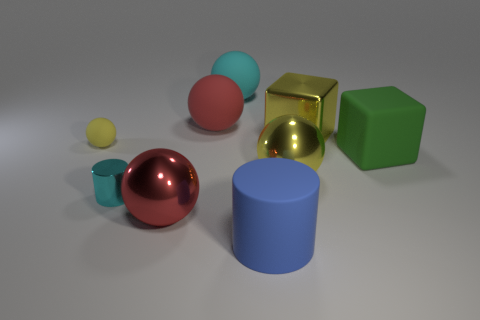Subtract all small yellow matte balls. How many balls are left? 4 Subtract all gray balls. Subtract all green cylinders. How many balls are left? 5 Add 1 large objects. How many objects exist? 10 Subtract all cylinders. How many objects are left? 7 Add 5 big matte cubes. How many big matte cubes exist? 6 Subtract 0 blue spheres. How many objects are left? 9 Subtract all tiny yellow cylinders. Subtract all big metallic balls. How many objects are left? 7 Add 2 big cyan rubber things. How many big cyan rubber things are left? 3 